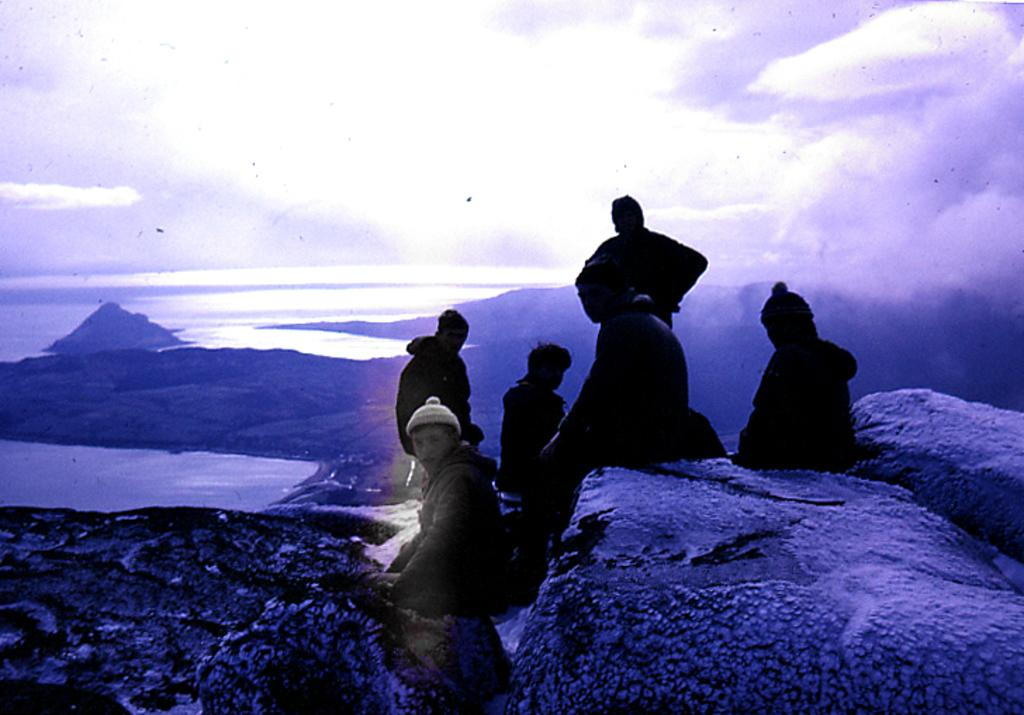What are the people in the image doing? The people in the image are seated. Is there anyone standing in the image? Yes, there is a man standing in the image. What are the people wearing on their heads? The people are wearing caps on their heads. What can be seen in the background of the image? There is water and rocks visible in the image. What is the condition of the sky in the image? The sky is cloudy in the image. What type of bubble can be seen floating near the rocks in the image? There is no bubble present in the image; it features people seated and standing, wearing caps, with water and rocks visible in the background, and a cloudy sky. 